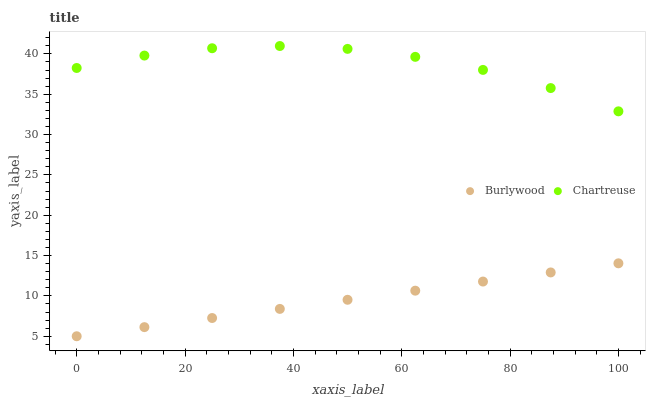Does Burlywood have the minimum area under the curve?
Answer yes or no. Yes. Does Chartreuse have the maximum area under the curve?
Answer yes or no. Yes. Does Chartreuse have the minimum area under the curve?
Answer yes or no. No. Is Burlywood the smoothest?
Answer yes or no. Yes. Is Chartreuse the roughest?
Answer yes or no. Yes. Is Chartreuse the smoothest?
Answer yes or no. No. Does Burlywood have the lowest value?
Answer yes or no. Yes. Does Chartreuse have the lowest value?
Answer yes or no. No. Does Chartreuse have the highest value?
Answer yes or no. Yes. Is Burlywood less than Chartreuse?
Answer yes or no. Yes. Is Chartreuse greater than Burlywood?
Answer yes or no. Yes. Does Burlywood intersect Chartreuse?
Answer yes or no. No. 